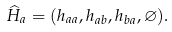Convert formula to latex. <formula><loc_0><loc_0><loc_500><loc_500>\widehat { H } _ { a } = ( h _ { a a } , h _ { a b } , h _ { b a } , \varnothing ) .</formula> 